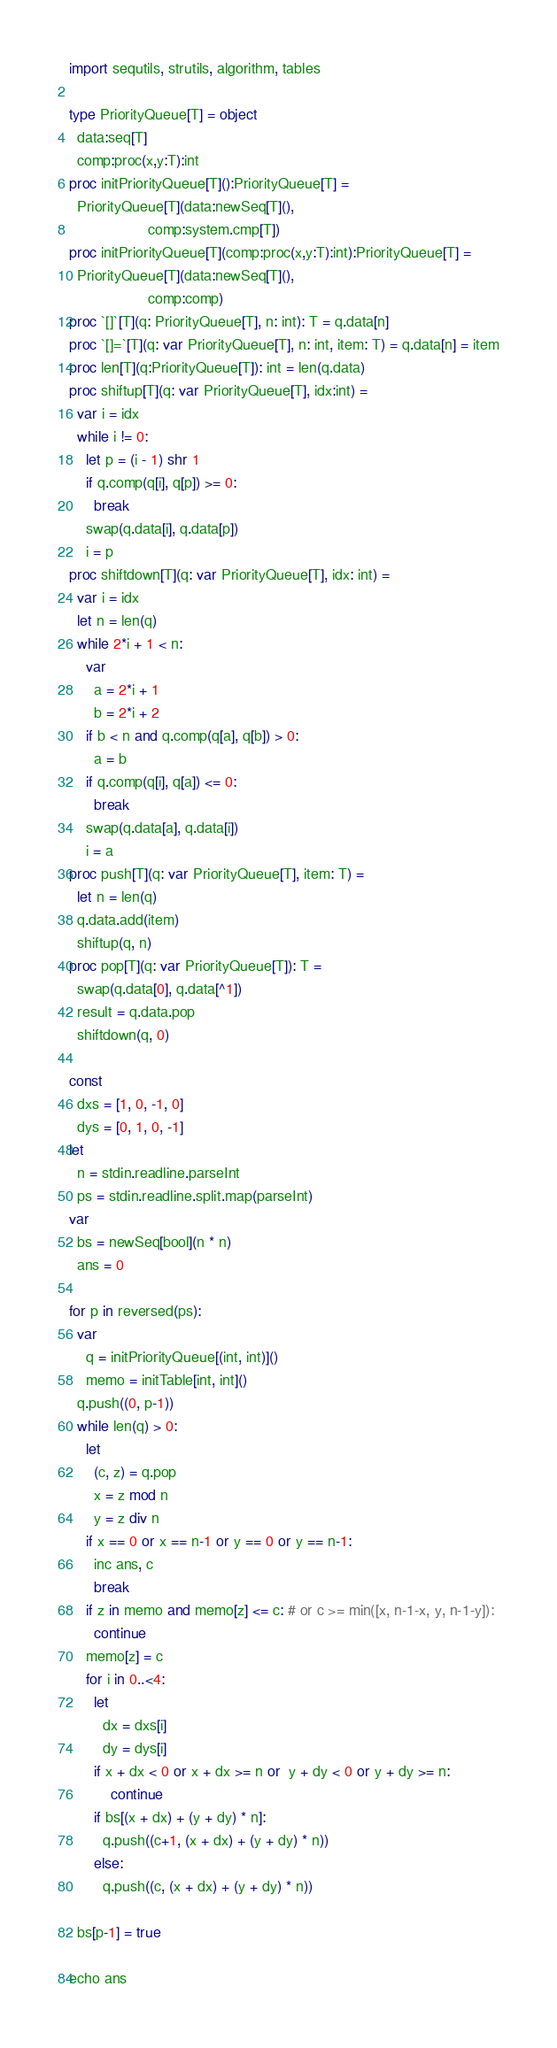<code> <loc_0><loc_0><loc_500><loc_500><_Nim_>import sequtils, strutils, algorithm, tables

type PriorityQueue[T] = object
  data:seq[T]
  comp:proc(x,y:T):int
proc initPriorityQueue[T]():PriorityQueue[T] =
  PriorityQueue[T](data:newSeq[T](),
                   comp:system.cmp[T])
proc initPriorityQueue[T](comp:proc(x,y:T):int):PriorityQueue[T] =
  PriorityQueue[T](data:newSeq[T](),
                   comp:comp)
proc `[]`[T](q: PriorityQueue[T], n: int): T = q.data[n]
proc `[]=`[T](q: var PriorityQueue[T], n: int, item: T) = q.data[n] = item
proc len[T](q:PriorityQueue[T]): int = len(q.data)
proc shiftup[T](q: var PriorityQueue[T], idx:int) =
  var i = idx
  while i != 0:
    let p = (i - 1) shr 1
    if q.comp(q[i], q[p]) >= 0:
      break
    swap(q.data[i], q.data[p])
    i = p
proc shiftdown[T](q: var PriorityQueue[T], idx: int) =
  var i = idx
  let n = len(q)
  while 2*i + 1 < n:
    var
      a = 2*i + 1
      b = 2*i + 2
    if b < n and q.comp(q[a], q[b]) > 0:
      a = b
    if q.comp(q[i], q[a]) <= 0:
      break
    swap(q.data[a], q.data[i])
    i = a
proc push[T](q: var PriorityQueue[T], item: T) =
  let n = len(q)
  q.data.add(item)
  shiftup(q, n)
proc pop[T](q: var PriorityQueue[T]): T =
  swap(q.data[0], q.data[^1])
  result = q.data.pop
  shiftdown(q, 0)

const
  dxs = [1, 0, -1, 0]
  dys = [0, 1, 0, -1]
let
  n = stdin.readline.parseInt
  ps = stdin.readline.split.map(parseInt)
var
  bs = newSeq[bool](n * n)
  ans = 0

for p in reversed(ps):
  var
    q = initPriorityQueue[(int, int)]()
    memo = initTable[int, int]()
  q.push((0, p-1))
  while len(q) > 0:
    let
      (c, z) = q.pop
      x = z mod n
      y = z div n
    if x == 0 or x == n-1 or y == 0 or y == n-1:
      inc ans, c
      break
    if z in memo and memo[z] <= c: # or c >= min([x, n-1-x, y, n-1-y]):
      continue
    memo[z] = c
    for i in 0..<4:
      let
        dx = dxs[i]
        dy = dys[i]
      if x + dx < 0 or x + dx >= n or  y + dy < 0 or y + dy >= n:
          continue
      if bs[(x + dx) + (y + dy) * n]:
        q.push((c+1, (x + dx) + (y + dy) * n))
      else:
        q.push((c, (x + dx) + (y + dy) * n))
 
  bs[p-1] = true

echo ans
</code> 